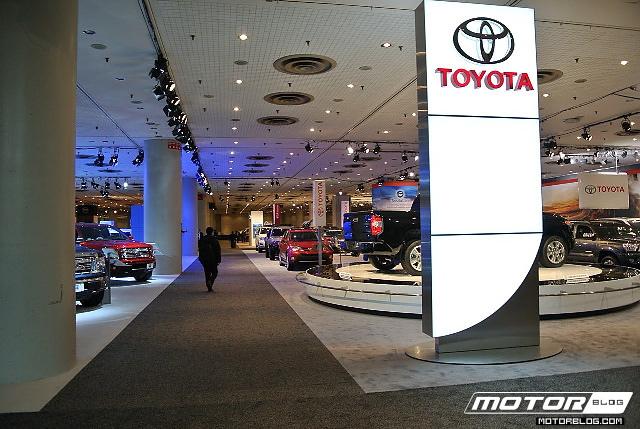What website did the photo belong to?
Quick response, please. Motorblogcom. How many people are in this photo?
Short answer required. 1. Which brand is seen?
Answer briefly. Toyota. What brand is this?
Short answer required. Toyota. 